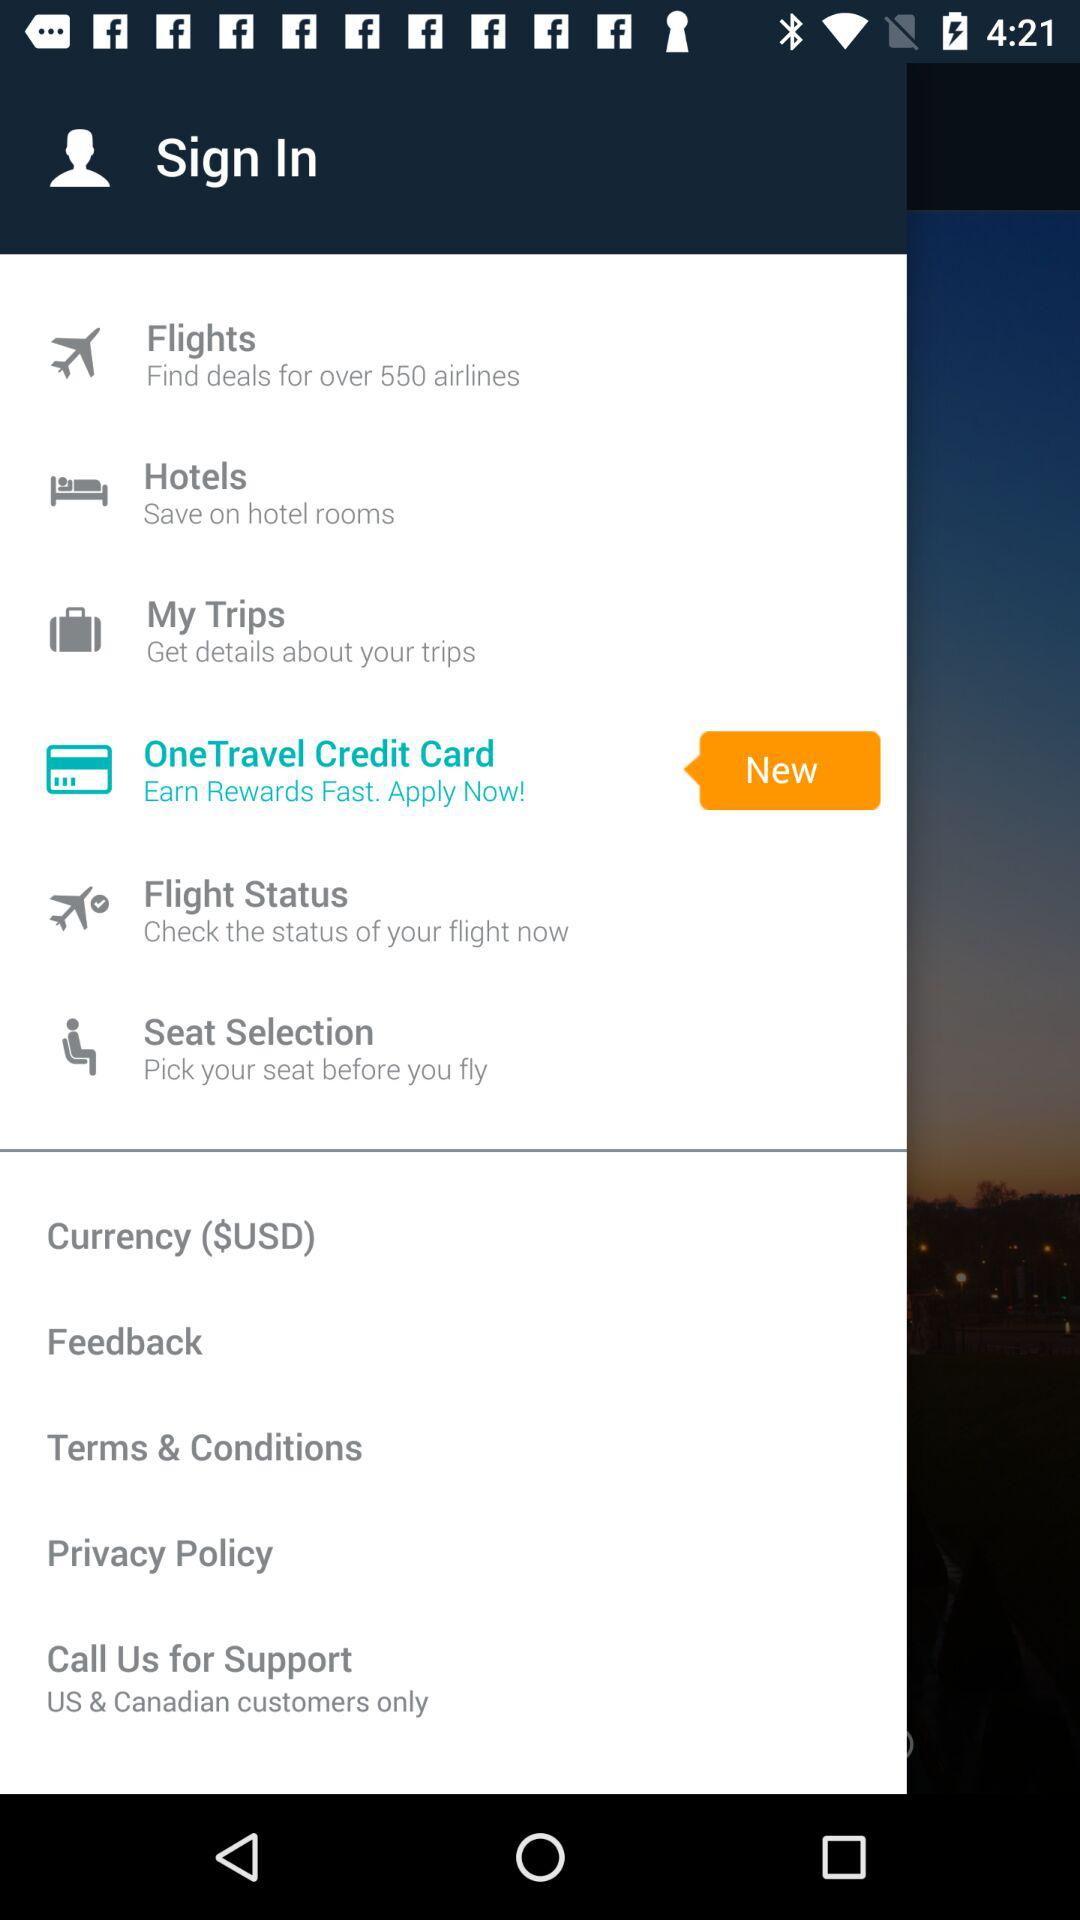Which seat was selected?
When the provided information is insufficient, respond with <no answer>. <no answer> 